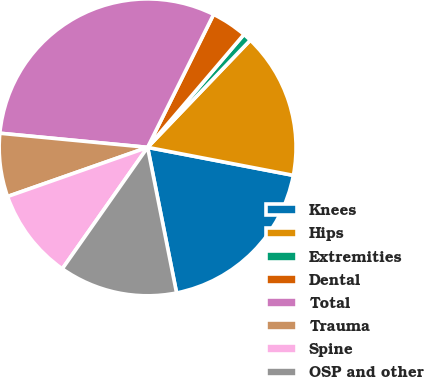Convert chart to OTSL. <chart><loc_0><loc_0><loc_500><loc_500><pie_chart><fcel>Knees<fcel>Hips<fcel>Extremities<fcel>Dental<fcel>Total<fcel>Trauma<fcel>Spine<fcel>OSP and other<nl><fcel>18.85%<fcel>15.86%<fcel>0.92%<fcel>3.91%<fcel>30.81%<fcel>6.89%<fcel>9.88%<fcel>12.87%<nl></chart> 